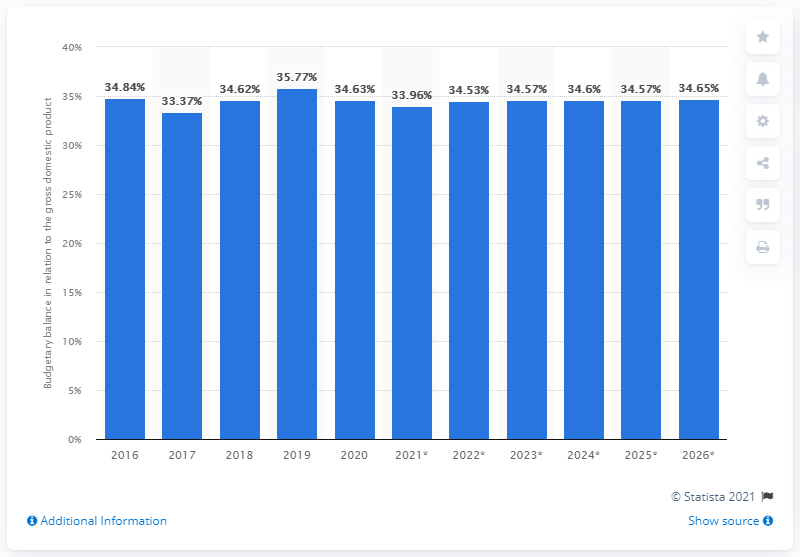Mention a couple of crucial points in this snapshot. In 2020, the ratio of government debt to the GDP in Turkey was 34.65. 